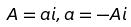Convert formula to latex. <formula><loc_0><loc_0><loc_500><loc_500>A = a i , a = - A i</formula> 